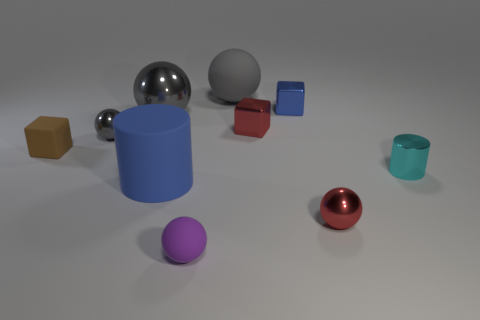How many big objects are either yellow rubber things or gray things?
Make the answer very short. 2. Does the matte object behind the small matte cube have the same shape as the tiny red object that is behind the rubber cylinder?
Give a very brief answer. No. What size is the block that is left of the small metallic ball that is left of the red shiny thing that is in front of the tiny rubber cube?
Provide a short and direct response. Small. There is a cylinder that is on the left side of the tiny cyan cylinder; how big is it?
Offer a terse response. Large. There is a gray object behind the blue metallic cube; what material is it?
Provide a succinct answer. Rubber. How many brown things are either large metal blocks or cylinders?
Offer a very short reply. 0. Do the purple object and the gray thing behind the small blue metal object have the same material?
Offer a terse response. Yes. Is the number of small cyan cylinders on the left side of the large gray shiny sphere the same as the number of blue metallic objects that are to the left of the purple object?
Make the answer very short. Yes. There is a gray rubber thing; does it have the same size as the cylinder that is on the right side of the small red metallic sphere?
Your answer should be very brief. No. Are there more tiny metallic cylinders on the left side of the small cylinder than cyan blocks?
Ensure brevity in your answer.  No. 